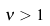Convert formula to latex. <formula><loc_0><loc_0><loc_500><loc_500>\nu > 1</formula> 